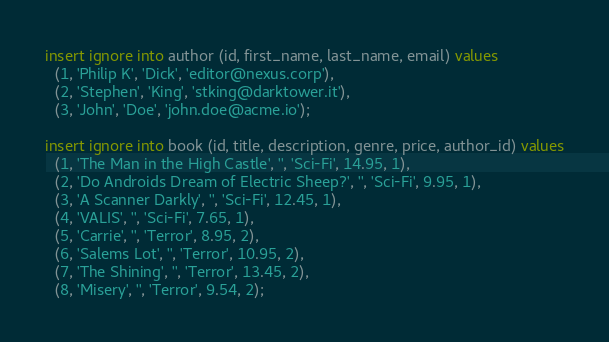<code> <loc_0><loc_0><loc_500><loc_500><_SQL_>insert ignore into author (id, first_name, last_name, email) values
  (1, 'Philip K', 'Dick', 'editor@nexus.corp'),
  (2, 'Stephen', 'King', 'stking@darktower.it'),
  (3, 'John', 'Doe', 'john.doe@acme.io');

insert ignore into book (id, title, description, genre, price, author_id) values
  (1, 'The Man in the High Castle', '', 'Sci-Fi', 14.95, 1),
  (2, 'Do Androids Dream of Electric Sheep?', '', 'Sci-Fi', 9.95, 1),
  (3, 'A Scanner Darkly', '', 'Sci-Fi', 12.45, 1),
  (4, 'VALIS', '', 'Sci-Fi', 7.65, 1),
  (5, 'Carrie', '', 'Terror', 8.95, 2),
  (6, 'Salems Lot', '', 'Terror', 10.95, 2),
  (7, 'The Shining', '', 'Terror', 13.45, 2),
  (8, 'Misery', '', 'Terror', 9.54, 2);</code> 